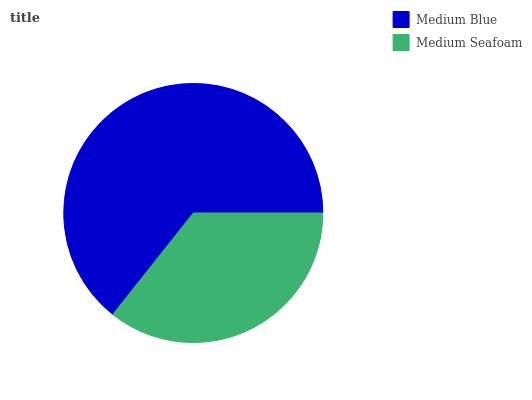Is Medium Seafoam the minimum?
Answer yes or no. Yes. Is Medium Blue the maximum?
Answer yes or no. Yes. Is Medium Seafoam the maximum?
Answer yes or no. No. Is Medium Blue greater than Medium Seafoam?
Answer yes or no. Yes. Is Medium Seafoam less than Medium Blue?
Answer yes or no. Yes. Is Medium Seafoam greater than Medium Blue?
Answer yes or no. No. Is Medium Blue less than Medium Seafoam?
Answer yes or no. No. Is Medium Blue the high median?
Answer yes or no. Yes. Is Medium Seafoam the low median?
Answer yes or no. Yes. Is Medium Seafoam the high median?
Answer yes or no. No. Is Medium Blue the low median?
Answer yes or no. No. 